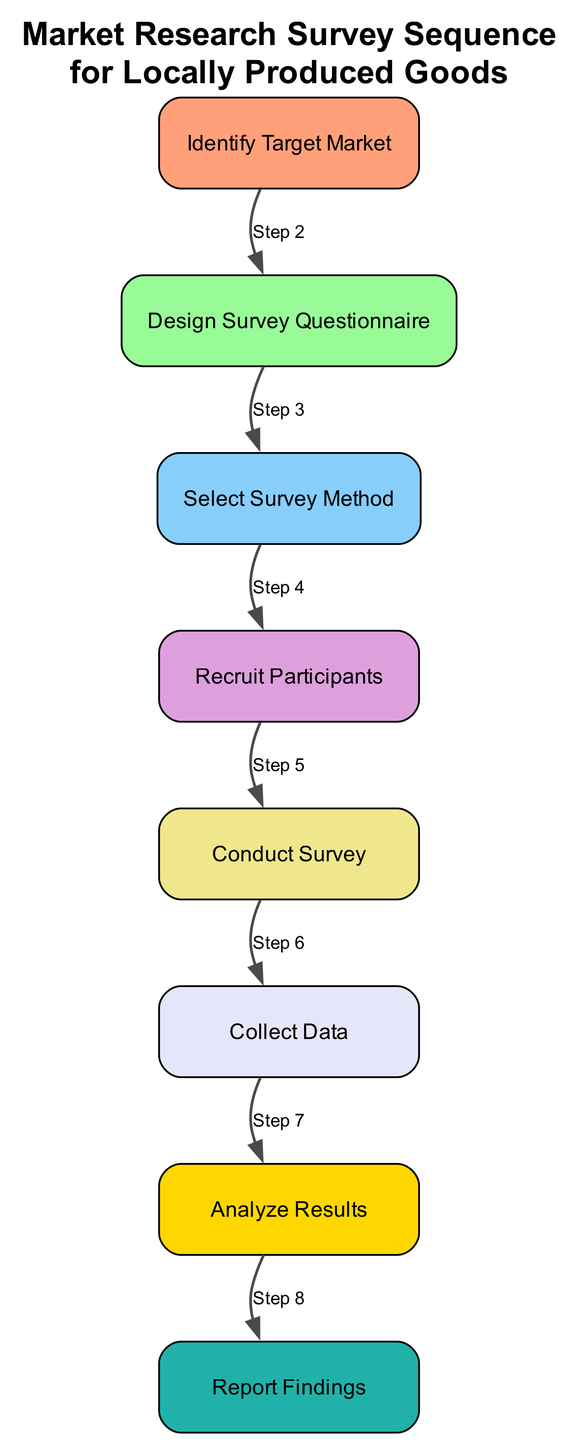What is the first step in the market research survey sequence? The first step in the sequence diagram is "Identify Target Market," which serves as the foundation for the subsequent steps in the market research process.
Answer: Identify Target Market How many total steps are outlined in the diagram? The diagram outlines a total of eight steps, each represented as nodes in the sequence. By counting the elements in the provided data, we see there are eight distinct stages in the process.
Answer: Eight What is the main objective of the "Design Survey Questionnaire" step? The objective of this step is to create questions that focus on consumer preferences, awareness, and willingness to purchase local products. This ensures that the survey captures relevant information.
Answer: Create questions on preferences Which step follows "Recruit Participants"? The step that follows "Recruit Participants" is "Conduct Survey." This indicates that once participants are recruited, the next action is to administer the survey to them.
Answer: Conduct Survey Which two steps are linked by the edge labeled "Step 5"? The edge labeled "Step 5" connects the "Conduct Survey" step to the "Collect Data" step. This indicates the flow from administering the survey to gathering the data from participants.
Answer: Conduct Survey to Collect Data What does “Report Findings” aim to summarize? "Report Findings" aims to summarize insights and recommendations based on the survey data collected during the earlier steps in the process. This step encapsulates the overall outcomes of the research.
Answer: Insights and recommendations What is the purpose of the "Select Survey Method" step in the process? The purpose of the "Select Survey Method" step is to choose a suitable method for conducting the survey, whether that is through online surveys, telephonic interviews, or in-person interviews, directly affecting participant engagement.
Answer: Choose survey method Which step precedes the data analysis? The step that precedes the data analysis is "Collect Data." This indicates that data needs to be gathered before it can be interpreted and analyzed for trends in consumer preferences.
Answer: Collect Data 